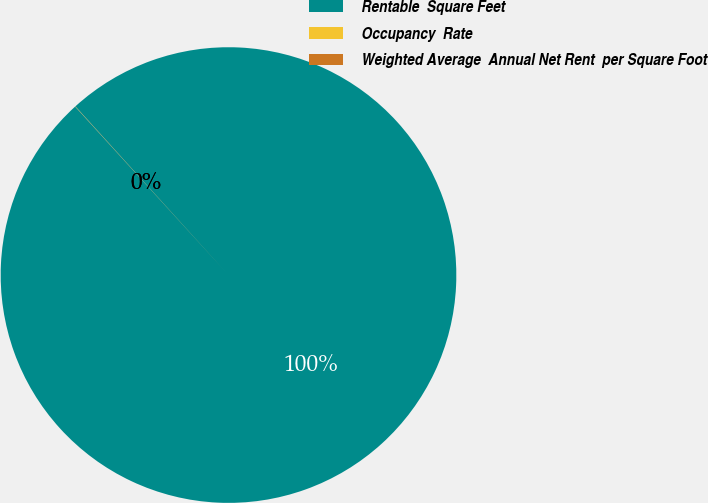Convert chart to OTSL. <chart><loc_0><loc_0><loc_500><loc_500><pie_chart><fcel>Rentable  Square Feet<fcel>Occupancy  Rate<fcel>Weighted Average  Annual Net Rent  per Square Foot<nl><fcel>99.98%<fcel>0.01%<fcel>0.01%<nl></chart> 